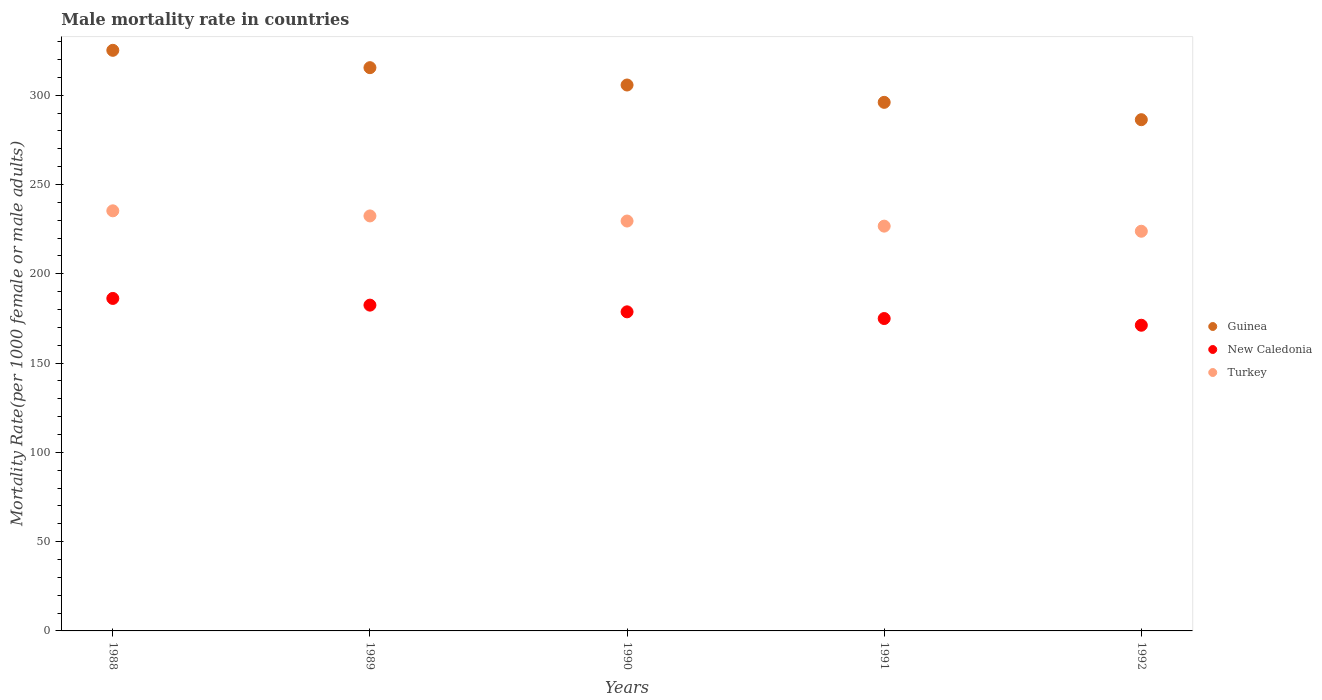How many different coloured dotlines are there?
Make the answer very short. 3. What is the male mortality rate in Guinea in 1988?
Offer a terse response. 325.1. Across all years, what is the maximum male mortality rate in Turkey?
Provide a succinct answer. 235.23. Across all years, what is the minimum male mortality rate in Guinea?
Provide a short and direct response. 286.26. In which year was the male mortality rate in Guinea minimum?
Make the answer very short. 1992. What is the total male mortality rate in New Caledonia in the graph?
Keep it short and to the point. 893.34. What is the difference between the male mortality rate in New Caledonia in 1988 and that in 1990?
Your answer should be compact. 7.5. What is the difference between the male mortality rate in Guinea in 1988 and the male mortality rate in New Caledonia in 1992?
Provide a short and direct response. 153.94. What is the average male mortality rate in Guinea per year?
Give a very brief answer. 305.68. In the year 1992, what is the difference between the male mortality rate in New Caledonia and male mortality rate in Turkey?
Keep it short and to the point. -52.63. In how many years, is the male mortality rate in Turkey greater than 50?
Your answer should be very brief. 5. What is the ratio of the male mortality rate in New Caledonia in 1988 to that in 1992?
Offer a very short reply. 1.09. Is the difference between the male mortality rate in New Caledonia in 1989 and 1992 greater than the difference between the male mortality rate in Turkey in 1989 and 1992?
Offer a terse response. Yes. What is the difference between the highest and the second highest male mortality rate in Turkey?
Keep it short and to the point. 2.86. What is the difference between the highest and the lowest male mortality rate in Turkey?
Offer a very short reply. 11.44. How many dotlines are there?
Offer a terse response. 3. How many years are there in the graph?
Keep it short and to the point. 5. Are the values on the major ticks of Y-axis written in scientific E-notation?
Offer a very short reply. No. Does the graph contain any zero values?
Give a very brief answer. No. How many legend labels are there?
Keep it short and to the point. 3. How are the legend labels stacked?
Your response must be concise. Vertical. What is the title of the graph?
Provide a short and direct response. Male mortality rate in countries. What is the label or title of the Y-axis?
Your answer should be very brief. Mortality Rate(per 1000 female or male adults). What is the Mortality Rate(per 1000 female or male adults) in Guinea in 1988?
Your answer should be very brief. 325.1. What is the Mortality Rate(per 1000 female or male adults) of New Caledonia in 1988?
Keep it short and to the point. 186.17. What is the Mortality Rate(per 1000 female or male adults) of Turkey in 1988?
Make the answer very short. 235.23. What is the Mortality Rate(per 1000 female or male adults) in Guinea in 1989?
Give a very brief answer. 315.39. What is the Mortality Rate(per 1000 female or male adults) in New Caledonia in 1989?
Your answer should be very brief. 182.42. What is the Mortality Rate(per 1000 female or male adults) in Turkey in 1989?
Provide a succinct answer. 232.37. What is the Mortality Rate(per 1000 female or male adults) in Guinea in 1990?
Ensure brevity in your answer.  305.68. What is the Mortality Rate(per 1000 female or male adults) in New Caledonia in 1990?
Make the answer very short. 178.67. What is the Mortality Rate(per 1000 female or male adults) in Turkey in 1990?
Your response must be concise. 229.51. What is the Mortality Rate(per 1000 female or male adults) in Guinea in 1991?
Offer a terse response. 295.97. What is the Mortality Rate(per 1000 female or male adults) of New Caledonia in 1991?
Your answer should be very brief. 174.92. What is the Mortality Rate(per 1000 female or male adults) in Turkey in 1991?
Offer a very short reply. 226.65. What is the Mortality Rate(per 1000 female or male adults) in Guinea in 1992?
Keep it short and to the point. 286.26. What is the Mortality Rate(per 1000 female or male adults) of New Caledonia in 1992?
Offer a terse response. 171.16. What is the Mortality Rate(per 1000 female or male adults) in Turkey in 1992?
Your answer should be very brief. 223.79. Across all years, what is the maximum Mortality Rate(per 1000 female or male adults) in Guinea?
Your response must be concise. 325.1. Across all years, what is the maximum Mortality Rate(per 1000 female or male adults) of New Caledonia?
Your response must be concise. 186.17. Across all years, what is the maximum Mortality Rate(per 1000 female or male adults) of Turkey?
Your response must be concise. 235.23. Across all years, what is the minimum Mortality Rate(per 1000 female or male adults) of Guinea?
Ensure brevity in your answer.  286.26. Across all years, what is the minimum Mortality Rate(per 1000 female or male adults) of New Caledonia?
Your answer should be compact. 171.16. Across all years, what is the minimum Mortality Rate(per 1000 female or male adults) in Turkey?
Make the answer very short. 223.79. What is the total Mortality Rate(per 1000 female or male adults) in Guinea in the graph?
Provide a succinct answer. 1528.39. What is the total Mortality Rate(per 1000 female or male adults) of New Caledonia in the graph?
Your answer should be compact. 893.34. What is the total Mortality Rate(per 1000 female or male adults) in Turkey in the graph?
Provide a succinct answer. 1147.56. What is the difference between the Mortality Rate(per 1000 female or male adults) of Guinea in 1988 and that in 1989?
Your response must be concise. 9.71. What is the difference between the Mortality Rate(per 1000 female or male adults) of New Caledonia in 1988 and that in 1989?
Offer a terse response. 3.75. What is the difference between the Mortality Rate(per 1000 female or male adults) of Turkey in 1988 and that in 1989?
Offer a very short reply. 2.86. What is the difference between the Mortality Rate(per 1000 female or male adults) of Guinea in 1988 and that in 1990?
Offer a terse response. 19.42. What is the difference between the Mortality Rate(per 1000 female or male adults) in New Caledonia in 1988 and that in 1990?
Make the answer very short. 7.5. What is the difference between the Mortality Rate(per 1000 female or male adults) of Turkey in 1988 and that in 1990?
Provide a short and direct response. 5.72. What is the difference between the Mortality Rate(per 1000 female or male adults) of Guinea in 1988 and that in 1991?
Your response must be concise. 29.13. What is the difference between the Mortality Rate(per 1000 female or male adults) of New Caledonia in 1988 and that in 1991?
Make the answer very short. 11.26. What is the difference between the Mortality Rate(per 1000 female or male adults) in Turkey in 1988 and that in 1991?
Provide a succinct answer. 8.58. What is the difference between the Mortality Rate(per 1000 female or male adults) of Guinea in 1988 and that in 1992?
Make the answer very short. 38.84. What is the difference between the Mortality Rate(per 1000 female or male adults) in New Caledonia in 1988 and that in 1992?
Ensure brevity in your answer.  15.01. What is the difference between the Mortality Rate(per 1000 female or male adults) in Turkey in 1988 and that in 1992?
Give a very brief answer. 11.44. What is the difference between the Mortality Rate(per 1000 female or male adults) in Guinea in 1989 and that in 1990?
Ensure brevity in your answer.  9.71. What is the difference between the Mortality Rate(per 1000 female or male adults) of New Caledonia in 1989 and that in 1990?
Provide a short and direct response. 3.75. What is the difference between the Mortality Rate(per 1000 female or male adults) in Turkey in 1989 and that in 1990?
Provide a succinct answer. 2.86. What is the difference between the Mortality Rate(per 1000 female or male adults) in Guinea in 1989 and that in 1991?
Keep it short and to the point. 19.42. What is the difference between the Mortality Rate(per 1000 female or male adults) of New Caledonia in 1989 and that in 1991?
Provide a succinct answer. 7.5. What is the difference between the Mortality Rate(per 1000 female or male adults) of Turkey in 1989 and that in 1991?
Your answer should be compact. 5.72. What is the difference between the Mortality Rate(per 1000 female or male adults) of Guinea in 1989 and that in 1992?
Offer a terse response. 29.13. What is the difference between the Mortality Rate(per 1000 female or male adults) in New Caledonia in 1989 and that in 1992?
Offer a terse response. 11.26. What is the difference between the Mortality Rate(per 1000 female or male adults) in Turkey in 1989 and that in 1992?
Give a very brief answer. 8.58. What is the difference between the Mortality Rate(per 1000 female or male adults) of Guinea in 1990 and that in 1991?
Your response must be concise. 9.71. What is the difference between the Mortality Rate(per 1000 female or male adults) in New Caledonia in 1990 and that in 1991?
Provide a short and direct response. 3.75. What is the difference between the Mortality Rate(per 1000 female or male adults) of Turkey in 1990 and that in 1991?
Give a very brief answer. 2.86. What is the difference between the Mortality Rate(per 1000 female or male adults) in Guinea in 1990 and that in 1992?
Ensure brevity in your answer.  19.42. What is the difference between the Mortality Rate(per 1000 female or male adults) in New Caledonia in 1990 and that in 1992?
Keep it short and to the point. 7.5. What is the difference between the Mortality Rate(per 1000 female or male adults) of Turkey in 1990 and that in 1992?
Your answer should be very brief. 5.72. What is the difference between the Mortality Rate(per 1000 female or male adults) in Guinea in 1991 and that in 1992?
Provide a succinct answer. 9.71. What is the difference between the Mortality Rate(per 1000 female or male adults) in New Caledonia in 1991 and that in 1992?
Give a very brief answer. 3.75. What is the difference between the Mortality Rate(per 1000 female or male adults) of Turkey in 1991 and that in 1992?
Offer a terse response. 2.86. What is the difference between the Mortality Rate(per 1000 female or male adults) of Guinea in 1988 and the Mortality Rate(per 1000 female or male adults) of New Caledonia in 1989?
Offer a very short reply. 142.68. What is the difference between the Mortality Rate(per 1000 female or male adults) in Guinea in 1988 and the Mortality Rate(per 1000 female or male adults) in Turkey in 1989?
Offer a terse response. 92.73. What is the difference between the Mortality Rate(per 1000 female or male adults) of New Caledonia in 1988 and the Mortality Rate(per 1000 female or male adults) of Turkey in 1989?
Your response must be concise. -46.2. What is the difference between the Mortality Rate(per 1000 female or male adults) in Guinea in 1988 and the Mortality Rate(per 1000 female or male adults) in New Caledonia in 1990?
Provide a succinct answer. 146.43. What is the difference between the Mortality Rate(per 1000 female or male adults) in Guinea in 1988 and the Mortality Rate(per 1000 female or male adults) in Turkey in 1990?
Offer a very short reply. 95.59. What is the difference between the Mortality Rate(per 1000 female or male adults) of New Caledonia in 1988 and the Mortality Rate(per 1000 female or male adults) of Turkey in 1990?
Your answer should be very brief. -43.34. What is the difference between the Mortality Rate(per 1000 female or male adults) in Guinea in 1988 and the Mortality Rate(per 1000 female or male adults) in New Caledonia in 1991?
Keep it short and to the point. 150.18. What is the difference between the Mortality Rate(per 1000 female or male adults) of Guinea in 1988 and the Mortality Rate(per 1000 female or male adults) of Turkey in 1991?
Make the answer very short. 98.45. What is the difference between the Mortality Rate(per 1000 female or male adults) of New Caledonia in 1988 and the Mortality Rate(per 1000 female or male adults) of Turkey in 1991?
Offer a terse response. -40.48. What is the difference between the Mortality Rate(per 1000 female or male adults) in Guinea in 1988 and the Mortality Rate(per 1000 female or male adults) in New Caledonia in 1992?
Give a very brief answer. 153.94. What is the difference between the Mortality Rate(per 1000 female or male adults) of Guinea in 1988 and the Mortality Rate(per 1000 female or male adults) of Turkey in 1992?
Give a very brief answer. 101.31. What is the difference between the Mortality Rate(per 1000 female or male adults) in New Caledonia in 1988 and the Mortality Rate(per 1000 female or male adults) in Turkey in 1992?
Offer a terse response. -37.62. What is the difference between the Mortality Rate(per 1000 female or male adults) of Guinea in 1989 and the Mortality Rate(per 1000 female or male adults) of New Caledonia in 1990?
Make the answer very short. 136.72. What is the difference between the Mortality Rate(per 1000 female or male adults) in Guinea in 1989 and the Mortality Rate(per 1000 female or male adults) in Turkey in 1990?
Ensure brevity in your answer.  85.88. What is the difference between the Mortality Rate(per 1000 female or male adults) of New Caledonia in 1989 and the Mortality Rate(per 1000 female or male adults) of Turkey in 1990?
Your answer should be very brief. -47.09. What is the difference between the Mortality Rate(per 1000 female or male adults) of Guinea in 1989 and the Mortality Rate(per 1000 female or male adults) of New Caledonia in 1991?
Your answer should be compact. 140.47. What is the difference between the Mortality Rate(per 1000 female or male adults) in Guinea in 1989 and the Mortality Rate(per 1000 female or male adults) in Turkey in 1991?
Offer a very short reply. 88.74. What is the difference between the Mortality Rate(per 1000 female or male adults) in New Caledonia in 1989 and the Mortality Rate(per 1000 female or male adults) in Turkey in 1991?
Provide a succinct answer. -44.23. What is the difference between the Mortality Rate(per 1000 female or male adults) of Guinea in 1989 and the Mortality Rate(per 1000 female or male adults) of New Caledonia in 1992?
Offer a terse response. 144.23. What is the difference between the Mortality Rate(per 1000 female or male adults) of Guinea in 1989 and the Mortality Rate(per 1000 female or male adults) of Turkey in 1992?
Provide a short and direct response. 91.6. What is the difference between the Mortality Rate(per 1000 female or male adults) of New Caledonia in 1989 and the Mortality Rate(per 1000 female or male adults) of Turkey in 1992?
Offer a very short reply. -41.37. What is the difference between the Mortality Rate(per 1000 female or male adults) of Guinea in 1990 and the Mortality Rate(per 1000 female or male adults) of New Caledonia in 1991?
Your response must be concise. 130.76. What is the difference between the Mortality Rate(per 1000 female or male adults) of Guinea in 1990 and the Mortality Rate(per 1000 female or male adults) of Turkey in 1991?
Your response must be concise. 79.03. What is the difference between the Mortality Rate(per 1000 female or male adults) in New Caledonia in 1990 and the Mortality Rate(per 1000 female or male adults) in Turkey in 1991?
Keep it short and to the point. -47.98. What is the difference between the Mortality Rate(per 1000 female or male adults) of Guinea in 1990 and the Mortality Rate(per 1000 female or male adults) of New Caledonia in 1992?
Your answer should be compact. 134.51. What is the difference between the Mortality Rate(per 1000 female or male adults) in Guinea in 1990 and the Mortality Rate(per 1000 female or male adults) in Turkey in 1992?
Your answer should be very brief. 81.89. What is the difference between the Mortality Rate(per 1000 female or male adults) of New Caledonia in 1990 and the Mortality Rate(per 1000 female or male adults) of Turkey in 1992?
Give a very brief answer. -45.12. What is the difference between the Mortality Rate(per 1000 female or male adults) in Guinea in 1991 and the Mortality Rate(per 1000 female or male adults) in New Caledonia in 1992?
Offer a very short reply. 124.8. What is the difference between the Mortality Rate(per 1000 female or male adults) in Guinea in 1991 and the Mortality Rate(per 1000 female or male adults) in Turkey in 1992?
Provide a short and direct response. 72.18. What is the difference between the Mortality Rate(per 1000 female or male adults) in New Caledonia in 1991 and the Mortality Rate(per 1000 female or male adults) in Turkey in 1992?
Provide a succinct answer. -48.88. What is the average Mortality Rate(per 1000 female or male adults) in Guinea per year?
Make the answer very short. 305.68. What is the average Mortality Rate(per 1000 female or male adults) in New Caledonia per year?
Keep it short and to the point. 178.67. What is the average Mortality Rate(per 1000 female or male adults) of Turkey per year?
Your response must be concise. 229.51. In the year 1988, what is the difference between the Mortality Rate(per 1000 female or male adults) of Guinea and Mortality Rate(per 1000 female or male adults) of New Caledonia?
Your answer should be very brief. 138.93. In the year 1988, what is the difference between the Mortality Rate(per 1000 female or male adults) of Guinea and Mortality Rate(per 1000 female or male adults) of Turkey?
Keep it short and to the point. 89.87. In the year 1988, what is the difference between the Mortality Rate(per 1000 female or male adults) in New Caledonia and Mortality Rate(per 1000 female or male adults) in Turkey?
Your response must be concise. -49.06. In the year 1989, what is the difference between the Mortality Rate(per 1000 female or male adults) of Guinea and Mortality Rate(per 1000 female or male adults) of New Caledonia?
Provide a succinct answer. 132.97. In the year 1989, what is the difference between the Mortality Rate(per 1000 female or male adults) in Guinea and Mortality Rate(per 1000 female or male adults) in Turkey?
Your response must be concise. 83.02. In the year 1989, what is the difference between the Mortality Rate(per 1000 female or male adults) in New Caledonia and Mortality Rate(per 1000 female or male adults) in Turkey?
Your answer should be very brief. -49.95. In the year 1990, what is the difference between the Mortality Rate(per 1000 female or male adults) of Guinea and Mortality Rate(per 1000 female or male adults) of New Caledonia?
Your response must be concise. 127.01. In the year 1990, what is the difference between the Mortality Rate(per 1000 female or male adults) in Guinea and Mortality Rate(per 1000 female or male adults) in Turkey?
Give a very brief answer. 76.17. In the year 1990, what is the difference between the Mortality Rate(per 1000 female or male adults) of New Caledonia and Mortality Rate(per 1000 female or male adults) of Turkey?
Give a very brief answer. -50.84. In the year 1991, what is the difference between the Mortality Rate(per 1000 female or male adults) of Guinea and Mortality Rate(per 1000 female or male adults) of New Caledonia?
Offer a very short reply. 121.05. In the year 1991, what is the difference between the Mortality Rate(per 1000 female or male adults) in Guinea and Mortality Rate(per 1000 female or male adults) in Turkey?
Give a very brief answer. 69.32. In the year 1991, what is the difference between the Mortality Rate(per 1000 female or male adults) in New Caledonia and Mortality Rate(per 1000 female or male adults) in Turkey?
Offer a terse response. -51.74. In the year 1992, what is the difference between the Mortality Rate(per 1000 female or male adults) of Guinea and Mortality Rate(per 1000 female or male adults) of New Caledonia?
Ensure brevity in your answer.  115.09. In the year 1992, what is the difference between the Mortality Rate(per 1000 female or male adults) of Guinea and Mortality Rate(per 1000 female or male adults) of Turkey?
Your response must be concise. 62.47. In the year 1992, what is the difference between the Mortality Rate(per 1000 female or male adults) of New Caledonia and Mortality Rate(per 1000 female or male adults) of Turkey?
Your response must be concise. -52.63. What is the ratio of the Mortality Rate(per 1000 female or male adults) in Guinea in 1988 to that in 1989?
Your answer should be compact. 1.03. What is the ratio of the Mortality Rate(per 1000 female or male adults) in New Caledonia in 1988 to that in 1989?
Offer a terse response. 1.02. What is the ratio of the Mortality Rate(per 1000 female or male adults) in Turkey in 1988 to that in 1989?
Keep it short and to the point. 1.01. What is the ratio of the Mortality Rate(per 1000 female or male adults) in Guinea in 1988 to that in 1990?
Your answer should be compact. 1.06. What is the ratio of the Mortality Rate(per 1000 female or male adults) of New Caledonia in 1988 to that in 1990?
Keep it short and to the point. 1.04. What is the ratio of the Mortality Rate(per 1000 female or male adults) of Turkey in 1988 to that in 1990?
Offer a terse response. 1.02. What is the ratio of the Mortality Rate(per 1000 female or male adults) of Guinea in 1988 to that in 1991?
Offer a terse response. 1.1. What is the ratio of the Mortality Rate(per 1000 female or male adults) of New Caledonia in 1988 to that in 1991?
Your answer should be compact. 1.06. What is the ratio of the Mortality Rate(per 1000 female or male adults) of Turkey in 1988 to that in 1991?
Keep it short and to the point. 1.04. What is the ratio of the Mortality Rate(per 1000 female or male adults) of Guinea in 1988 to that in 1992?
Your response must be concise. 1.14. What is the ratio of the Mortality Rate(per 1000 female or male adults) of New Caledonia in 1988 to that in 1992?
Provide a short and direct response. 1.09. What is the ratio of the Mortality Rate(per 1000 female or male adults) of Turkey in 1988 to that in 1992?
Ensure brevity in your answer.  1.05. What is the ratio of the Mortality Rate(per 1000 female or male adults) in Guinea in 1989 to that in 1990?
Make the answer very short. 1.03. What is the ratio of the Mortality Rate(per 1000 female or male adults) in New Caledonia in 1989 to that in 1990?
Your response must be concise. 1.02. What is the ratio of the Mortality Rate(per 1000 female or male adults) of Turkey in 1989 to that in 1990?
Provide a succinct answer. 1.01. What is the ratio of the Mortality Rate(per 1000 female or male adults) in Guinea in 1989 to that in 1991?
Provide a short and direct response. 1.07. What is the ratio of the Mortality Rate(per 1000 female or male adults) in New Caledonia in 1989 to that in 1991?
Ensure brevity in your answer.  1.04. What is the ratio of the Mortality Rate(per 1000 female or male adults) of Turkey in 1989 to that in 1991?
Offer a terse response. 1.03. What is the ratio of the Mortality Rate(per 1000 female or male adults) of Guinea in 1989 to that in 1992?
Ensure brevity in your answer.  1.1. What is the ratio of the Mortality Rate(per 1000 female or male adults) in New Caledonia in 1989 to that in 1992?
Ensure brevity in your answer.  1.07. What is the ratio of the Mortality Rate(per 1000 female or male adults) in Turkey in 1989 to that in 1992?
Make the answer very short. 1.04. What is the ratio of the Mortality Rate(per 1000 female or male adults) in Guinea in 1990 to that in 1991?
Give a very brief answer. 1.03. What is the ratio of the Mortality Rate(per 1000 female or male adults) of New Caledonia in 1990 to that in 1991?
Your answer should be very brief. 1.02. What is the ratio of the Mortality Rate(per 1000 female or male adults) in Turkey in 1990 to that in 1991?
Your answer should be compact. 1.01. What is the ratio of the Mortality Rate(per 1000 female or male adults) in Guinea in 1990 to that in 1992?
Offer a very short reply. 1.07. What is the ratio of the Mortality Rate(per 1000 female or male adults) of New Caledonia in 1990 to that in 1992?
Ensure brevity in your answer.  1.04. What is the ratio of the Mortality Rate(per 1000 female or male adults) of Turkey in 1990 to that in 1992?
Your answer should be very brief. 1.03. What is the ratio of the Mortality Rate(per 1000 female or male adults) in Guinea in 1991 to that in 1992?
Offer a very short reply. 1.03. What is the ratio of the Mortality Rate(per 1000 female or male adults) of New Caledonia in 1991 to that in 1992?
Ensure brevity in your answer.  1.02. What is the ratio of the Mortality Rate(per 1000 female or male adults) of Turkey in 1991 to that in 1992?
Offer a very short reply. 1.01. What is the difference between the highest and the second highest Mortality Rate(per 1000 female or male adults) of Guinea?
Offer a very short reply. 9.71. What is the difference between the highest and the second highest Mortality Rate(per 1000 female or male adults) of New Caledonia?
Provide a succinct answer. 3.75. What is the difference between the highest and the second highest Mortality Rate(per 1000 female or male adults) in Turkey?
Provide a short and direct response. 2.86. What is the difference between the highest and the lowest Mortality Rate(per 1000 female or male adults) of Guinea?
Provide a short and direct response. 38.84. What is the difference between the highest and the lowest Mortality Rate(per 1000 female or male adults) in New Caledonia?
Keep it short and to the point. 15.01. What is the difference between the highest and the lowest Mortality Rate(per 1000 female or male adults) in Turkey?
Your response must be concise. 11.44. 